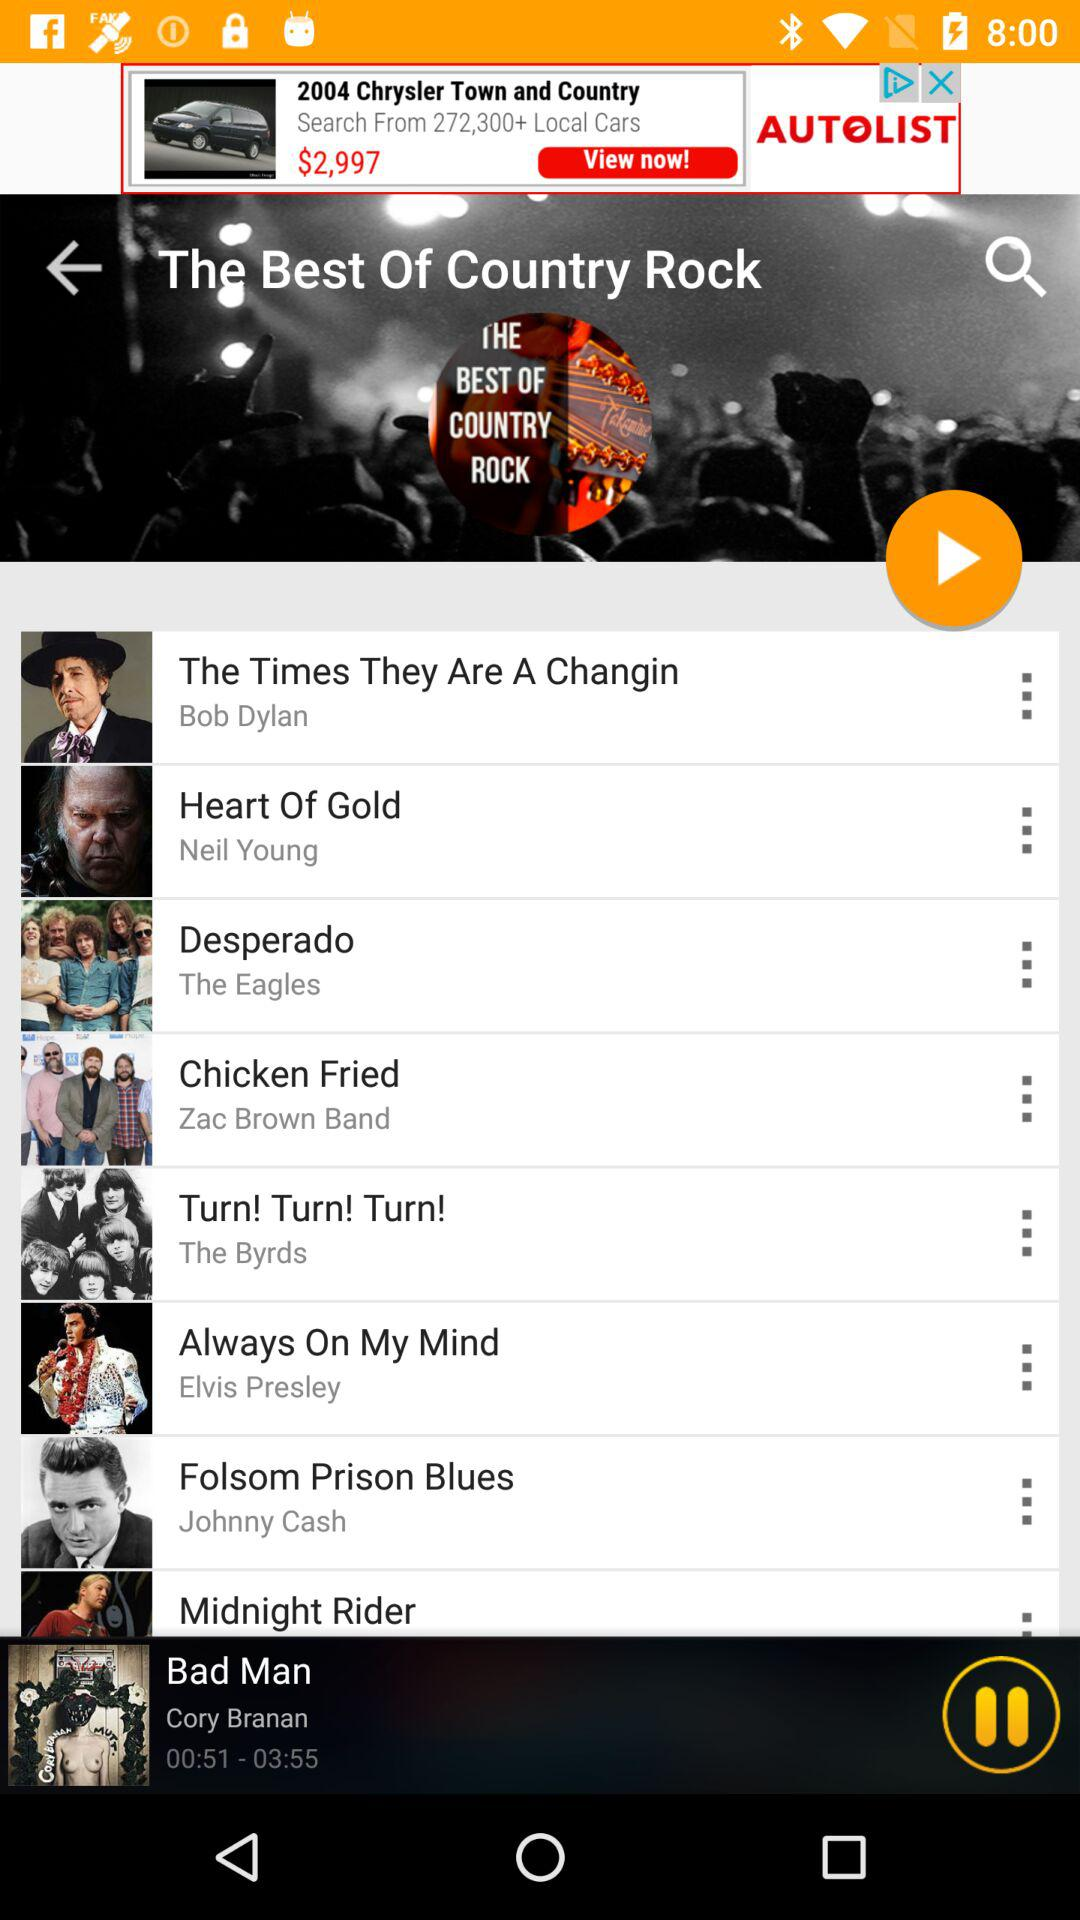What is the duration of the "Bad Man" song? The duration of the "Bad Man" song is 3 minutes 55 seconds. 